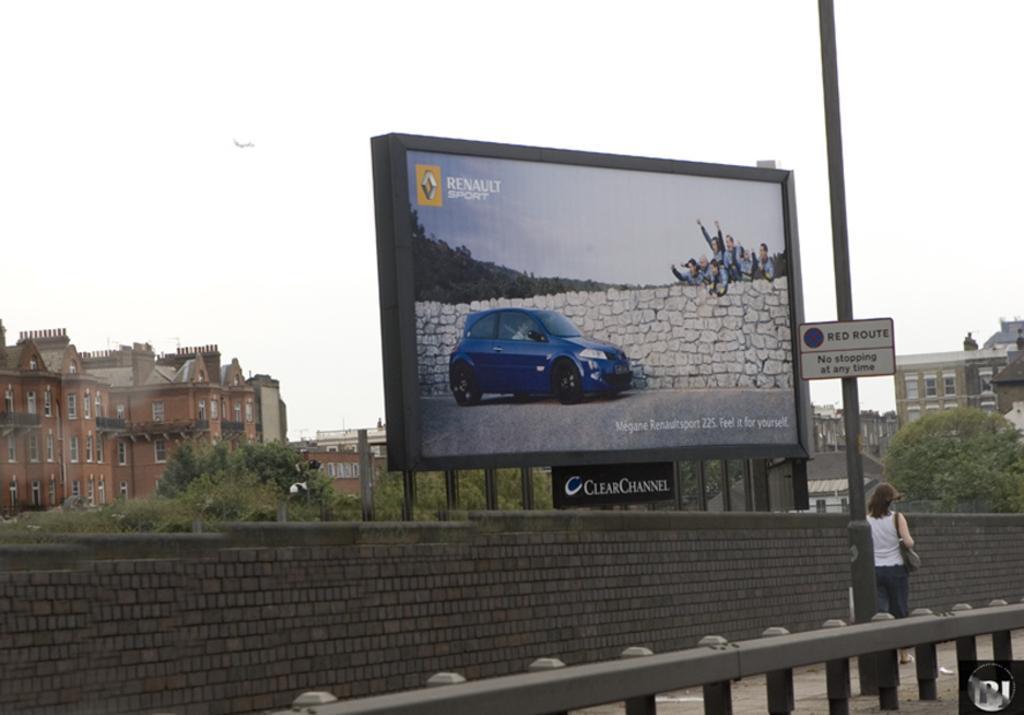Could you give a brief overview of what you see in this image? There is a woman walking and work bag. We can see wall,board on pole,fence and hoarding. In the background we can see trees,buildings and sky. 